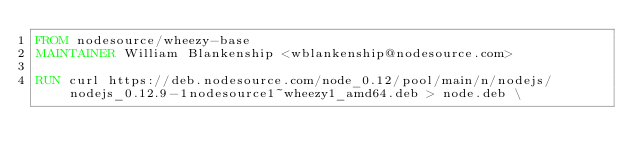<code> <loc_0><loc_0><loc_500><loc_500><_Dockerfile_>FROM nodesource/wheezy-base
MAINTAINER William Blankenship <wblankenship@nodesource.com>

RUN curl https://deb.nodesource.com/node_0.12/pool/main/n/nodejs/nodejs_0.12.9-1nodesource1~wheezy1_amd64.deb > node.deb \</code> 